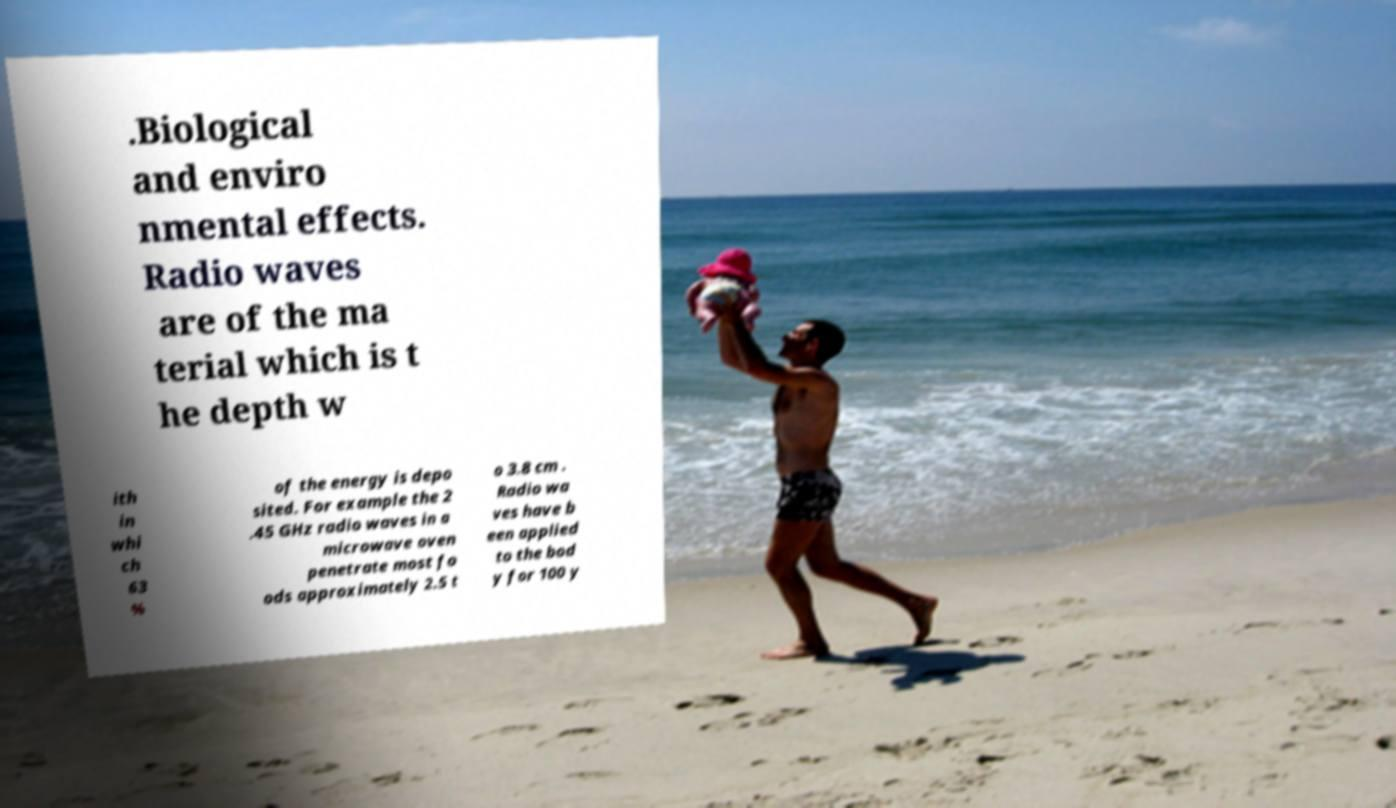Please read and relay the text visible in this image. What does it say? .Biological and enviro nmental effects. Radio waves are of the ma terial which is t he depth w ith in whi ch 63 % of the energy is depo sited. For example the 2 .45 GHz radio waves in a microwave oven penetrate most fo ods approximately 2.5 t o 3.8 cm . Radio wa ves have b een applied to the bod y for 100 y 